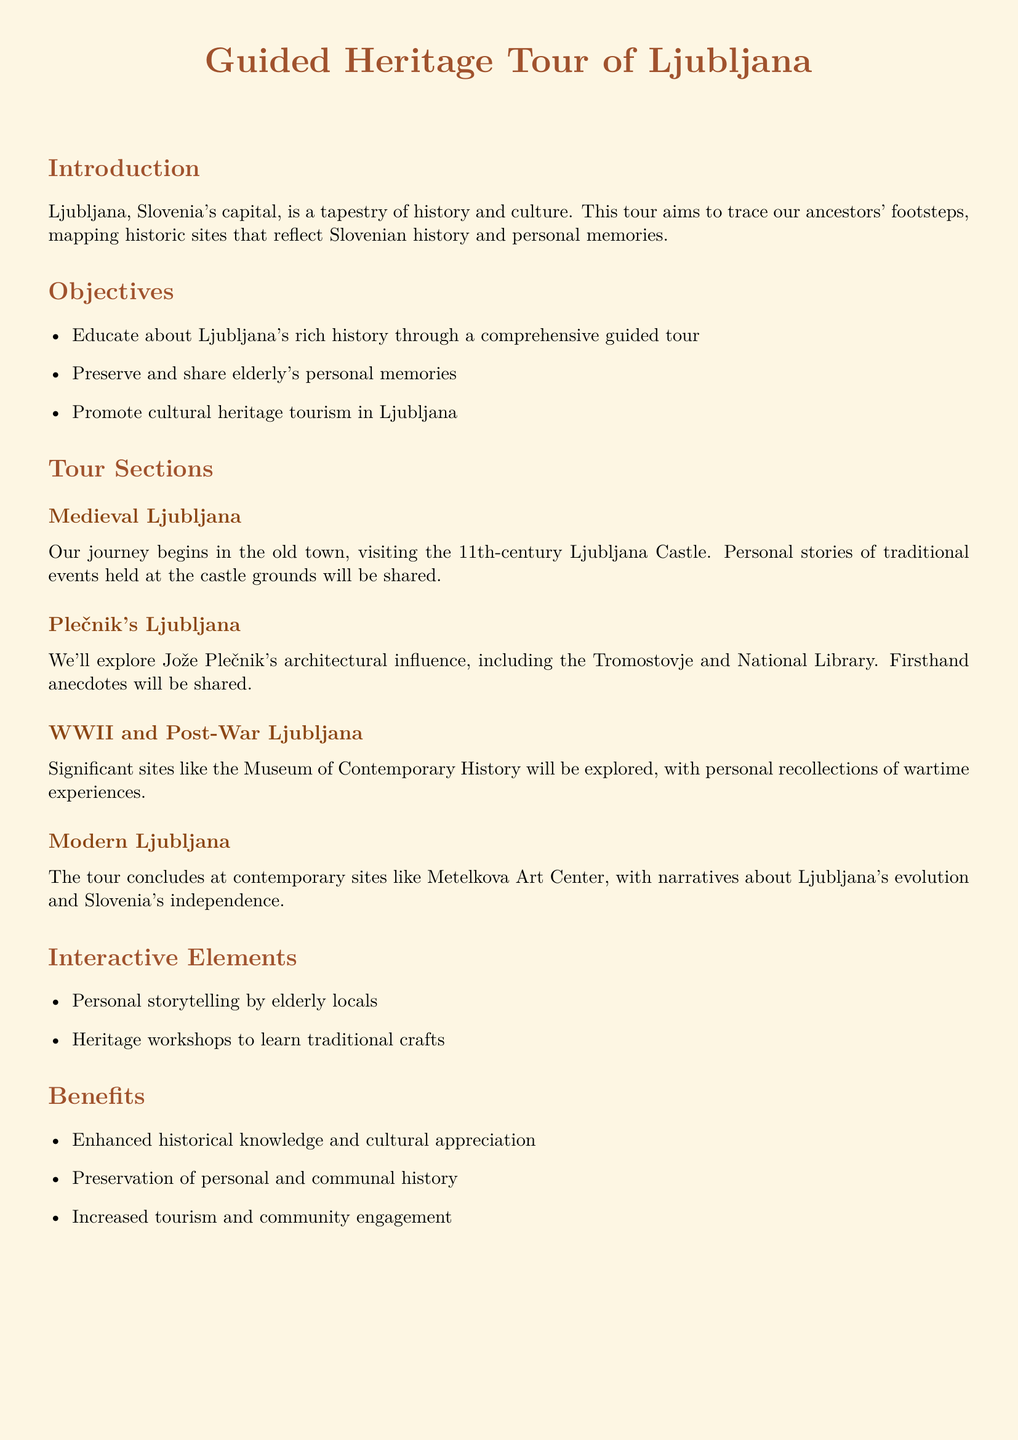What is the main focus of the tour? The tour aims to trace ancestors' footsteps by mapping historic sites that reflect Slovenian history and personal memories.
Answer: mapping historic sites What is one of the objectives of the tour? Objectives include educating about Ljubljana's rich history through a comprehensive guided tour.
Answer: Educate about Ljubljana's rich history What site marks the beginning of the tour? The journey begins in the old town, visiting the 11th-century Ljubljana Castle.
Answer: Ljubljana Castle What architectural influence will be explored during the tour? The tour will explore Jože Plečnik's architectural influence, including the Tromostovje and National Library.
Answer: Jože Plečnik What significant historical period will the tour cover? The tour will cover significant sites related to WWII and Post-War Ljubljana.
Answer: WWII and Post-War What type of storytelling is included in the interactive elements? Personal storytelling by elderly locals is included in the interactive elements.
Answer: Elderly locals What is one benefit of the tour? One benefit is the preservation of personal and communal history.
Answer: Preservation of history How many steps are listed in the next steps section? There are four steps listed in the next steps section.
Answer: Four steps 